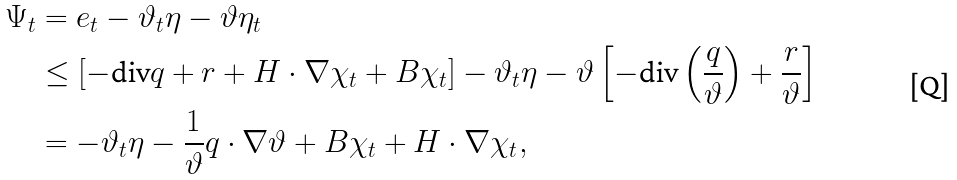<formula> <loc_0><loc_0><loc_500><loc_500>\Psi _ { t } & = e _ { t } - \vartheta _ { t } \eta - \vartheta \eta _ { t } \\ & \leq \left [ - \text {div} q + r + H \cdot \nabla \chi _ { t } + B \chi _ { t } \right ] - \vartheta _ { t } \eta - \vartheta \left [ - \text {div} \left ( \frac { q } { \vartheta } \right ) + \frac { r } { \vartheta } \right ] \\ & = - \vartheta _ { t } \eta - \frac { 1 } { \vartheta } q \cdot \nabla \vartheta + B \chi _ { t } + H \cdot \nabla \chi _ { t } ,</formula> 